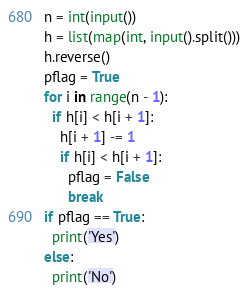<code> <loc_0><loc_0><loc_500><loc_500><_Python_>n = int(input())
h = list(map(int, input().split()))
h.reverse()
pflag = True
for i in range(n - 1):
  if h[i] < h[i + 1]:
    h[i + 1] -= 1
    if h[i] < h[i + 1]:
      pflag = False
      break
if pflag == True:
  print('Yes')
else:
  print('No')</code> 